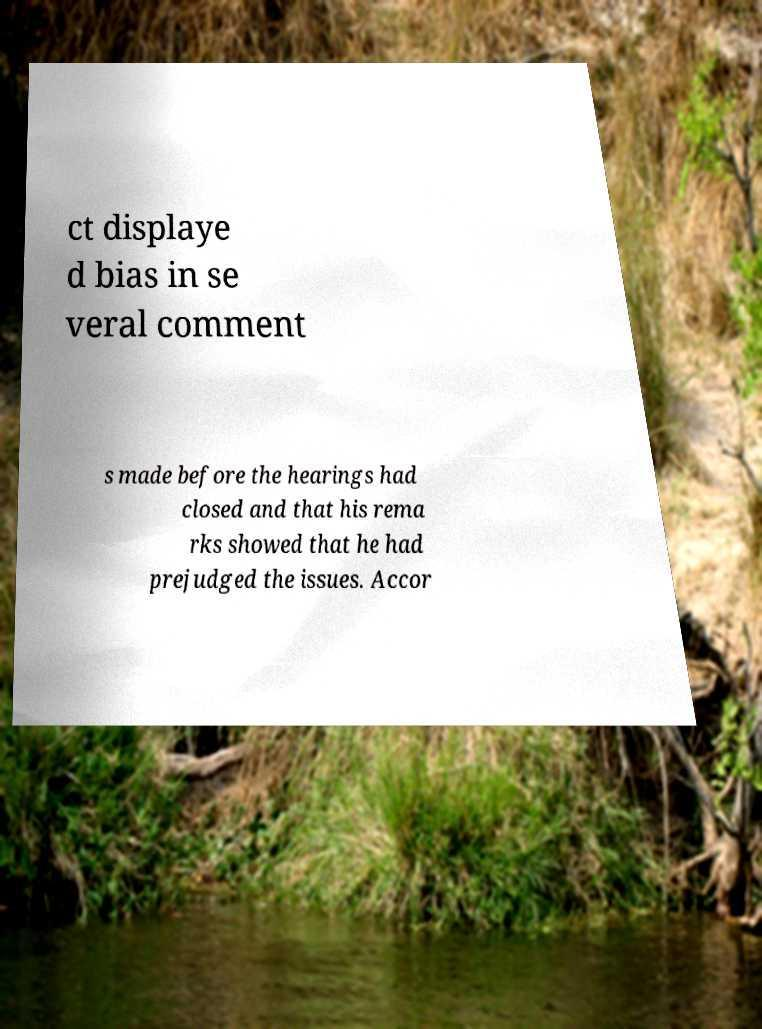Can you read and provide the text displayed in the image?This photo seems to have some interesting text. Can you extract and type it out for me? ct displaye d bias in se veral comment s made before the hearings had closed and that his rema rks showed that he had prejudged the issues. Accor 